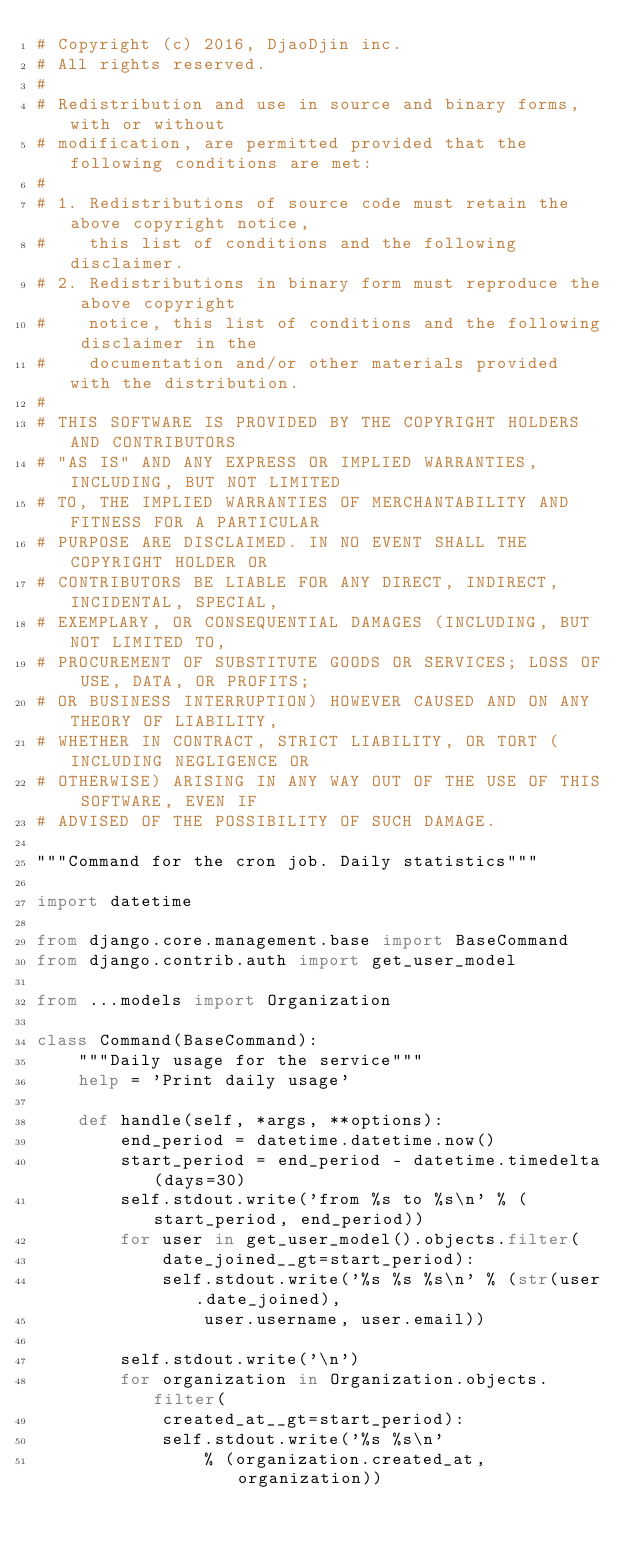Convert code to text. <code><loc_0><loc_0><loc_500><loc_500><_Python_># Copyright (c) 2016, DjaoDjin inc.
# All rights reserved.
#
# Redistribution and use in source and binary forms, with or without
# modification, are permitted provided that the following conditions are met:
#
# 1. Redistributions of source code must retain the above copyright notice,
#    this list of conditions and the following disclaimer.
# 2. Redistributions in binary form must reproduce the above copyright
#    notice, this list of conditions and the following disclaimer in the
#    documentation and/or other materials provided with the distribution.
#
# THIS SOFTWARE IS PROVIDED BY THE COPYRIGHT HOLDERS AND CONTRIBUTORS
# "AS IS" AND ANY EXPRESS OR IMPLIED WARRANTIES, INCLUDING, BUT NOT LIMITED
# TO, THE IMPLIED WARRANTIES OF MERCHANTABILITY AND FITNESS FOR A PARTICULAR
# PURPOSE ARE DISCLAIMED. IN NO EVENT SHALL THE COPYRIGHT HOLDER OR
# CONTRIBUTORS BE LIABLE FOR ANY DIRECT, INDIRECT, INCIDENTAL, SPECIAL,
# EXEMPLARY, OR CONSEQUENTIAL DAMAGES (INCLUDING, BUT NOT LIMITED TO,
# PROCUREMENT OF SUBSTITUTE GOODS OR SERVICES; LOSS OF USE, DATA, OR PROFITS;
# OR BUSINESS INTERRUPTION) HOWEVER CAUSED AND ON ANY THEORY OF LIABILITY,
# WHETHER IN CONTRACT, STRICT LIABILITY, OR TORT (INCLUDING NEGLIGENCE OR
# OTHERWISE) ARISING IN ANY WAY OUT OF THE USE OF THIS SOFTWARE, EVEN IF
# ADVISED OF THE POSSIBILITY OF SUCH DAMAGE.

"""Command for the cron job. Daily statistics"""

import datetime

from django.core.management.base import BaseCommand
from django.contrib.auth import get_user_model

from ...models import Organization

class Command(BaseCommand):
    """Daily usage for the service"""
    help = 'Print daily usage'

    def handle(self, *args, **options):
        end_period = datetime.datetime.now()
        start_period = end_period - datetime.timedelta(days=30)
        self.stdout.write('from %s to %s\n' % (start_period, end_period))
        for user in get_user_model().objects.filter(
            date_joined__gt=start_period):
            self.stdout.write('%s %s %s\n' % (str(user.date_joined),
                user.username, user.email))

        self.stdout.write('\n')
        for organization in Organization.objects.filter(
            created_at__gt=start_period):
            self.stdout.write('%s %s\n'
                % (organization.created_at, organization))
</code> 